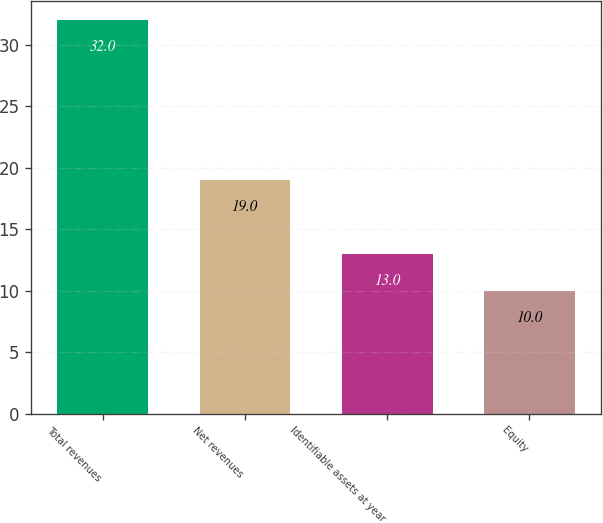Convert chart to OTSL. <chart><loc_0><loc_0><loc_500><loc_500><bar_chart><fcel>Total revenues<fcel>Net revenues<fcel>Identifiable assets at year<fcel>Equity<nl><fcel>32<fcel>19<fcel>13<fcel>10<nl></chart> 